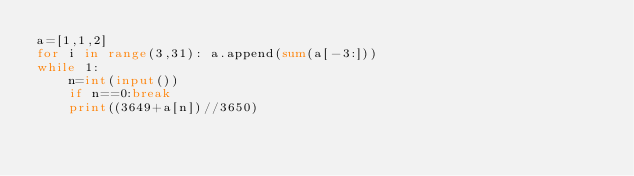Convert code to text. <code><loc_0><loc_0><loc_500><loc_500><_Python_>a=[1,1,2]
for i in range(3,31): a.append(sum(a[-3:]))
while 1:
    n=int(input())
    if n==0:break
    print((3649+a[n])//3650)</code> 